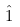Convert formula to latex. <formula><loc_0><loc_0><loc_500><loc_500>\hat { 1 }</formula> 